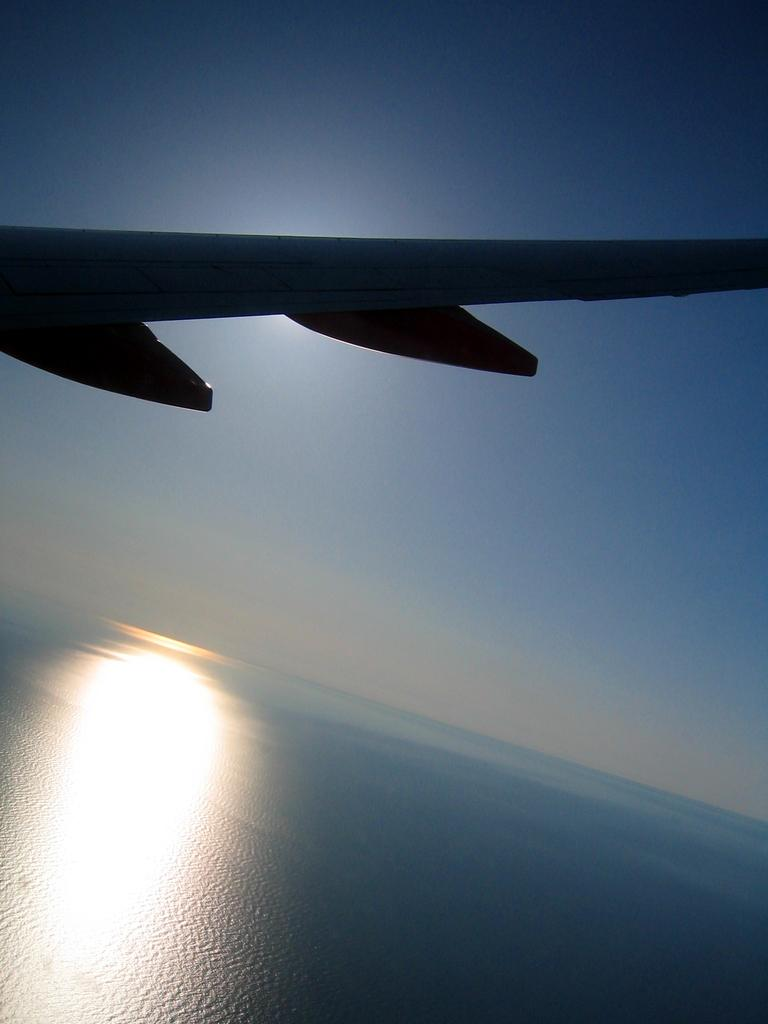What is the main subject of the image? The main subject of the image is an airplane. Can you describe the location of the airplane in the image? The airplane is in the air in the image. What can be seen in the background of the image? The sky is visible in the background of the image. What type of sugar is being used to sweeten the plate in the image? There is no sugar or plate present in the image; it features an airplane in the sky. 